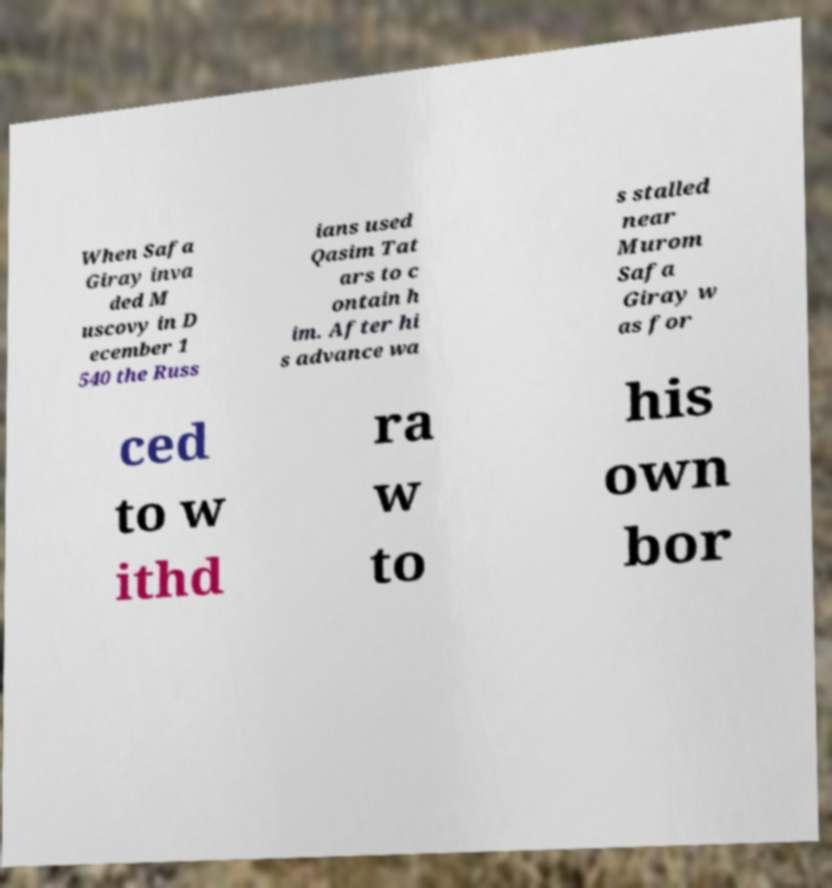Could you assist in decoding the text presented in this image and type it out clearly? When Safa Giray inva ded M uscovy in D ecember 1 540 the Russ ians used Qasim Tat ars to c ontain h im. After hi s advance wa s stalled near Murom Safa Giray w as for ced to w ithd ra w to his own bor 